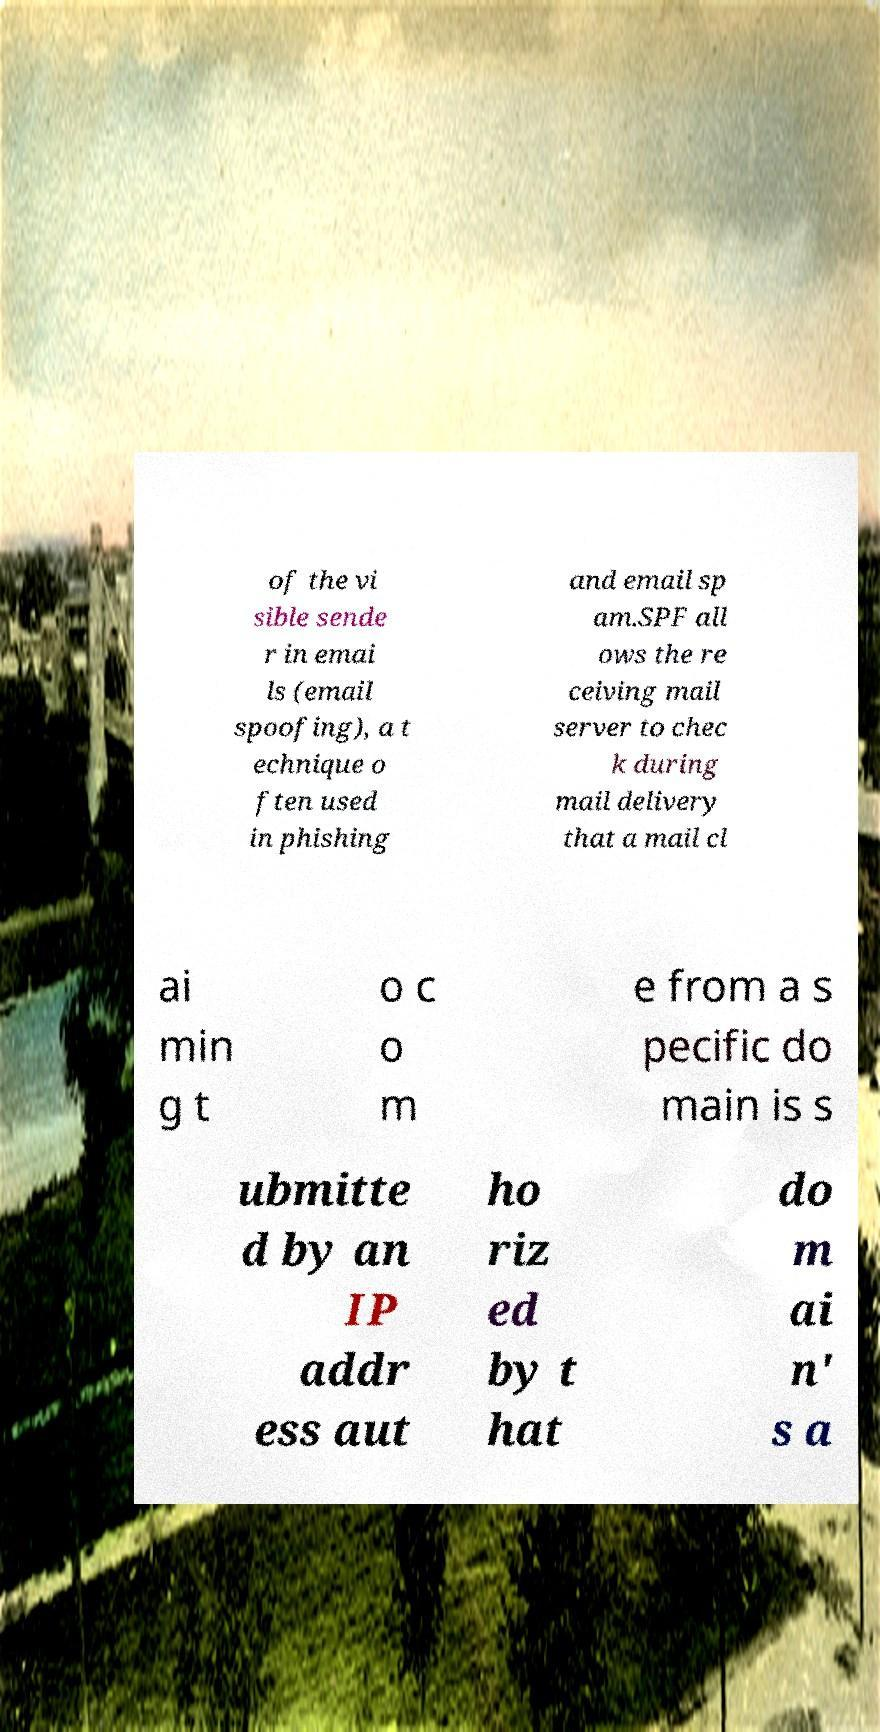Can you read and provide the text displayed in the image?This photo seems to have some interesting text. Can you extract and type it out for me? of the vi sible sende r in emai ls (email spoofing), a t echnique o ften used in phishing and email sp am.SPF all ows the re ceiving mail server to chec k during mail delivery that a mail cl ai min g t o c o m e from a s pecific do main is s ubmitte d by an IP addr ess aut ho riz ed by t hat do m ai n' s a 